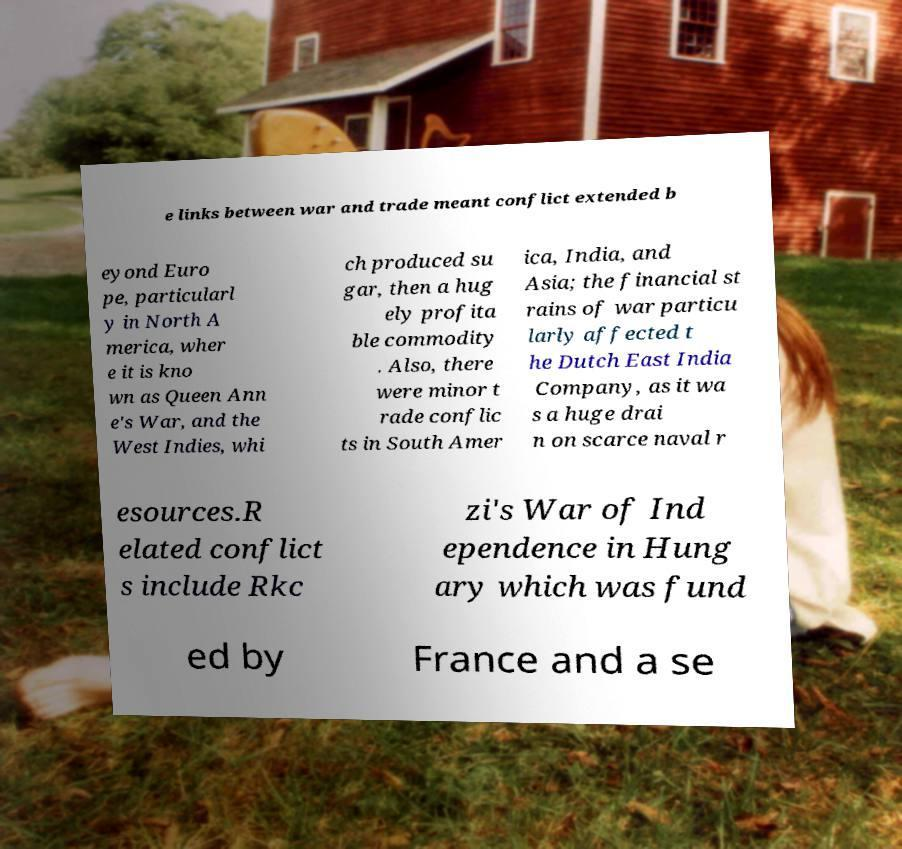Please read and relay the text visible in this image. What does it say? e links between war and trade meant conflict extended b eyond Euro pe, particularl y in North A merica, wher e it is kno wn as Queen Ann e's War, and the West Indies, whi ch produced su gar, then a hug ely profita ble commodity . Also, there were minor t rade conflic ts in South Amer ica, India, and Asia; the financial st rains of war particu larly affected t he Dutch East India Company, as it wa s a huge drai n on scarce naval r esources.R elated conflict s include Rkc zi's War of Ind ependence in Hung ary which was fund ed by France and a se 